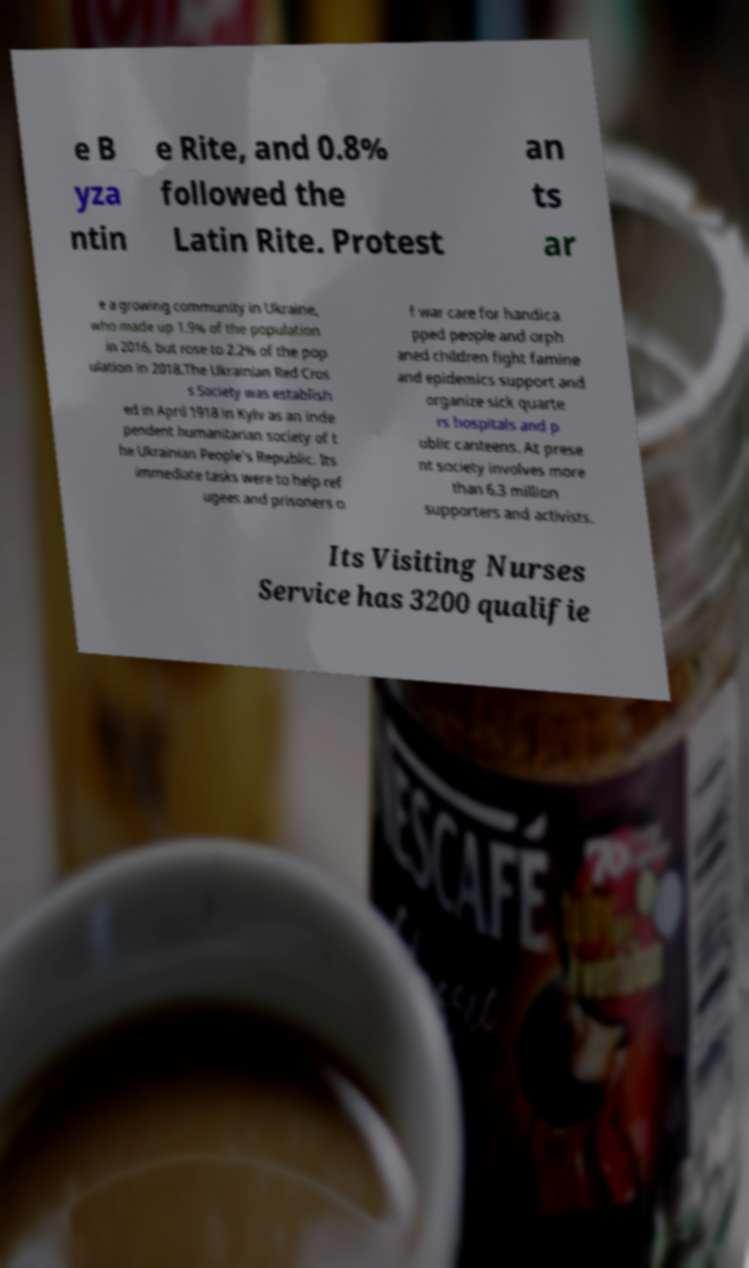Please identify and transcribe the text found in this image. e B yza ntin e Rite, and 0.8% followed the Latin Rite. Protest an ts ar e a growing community in Ukraine, who made up 1.9% of the population in 2016, but rose to 2.2% of the pop ulation in 2018.The Ukrainian Red Cros s Society was establish ed in April 1918 in Kyiv as an inde pendent humanitarian society of t he Ukrainian People's Republic. Its immediate tasks were to help ref ugees and prisoners o f war care for handica pped people and orph aned children fight famine and epidemics support and organize sick quarte rs hospitals and p ublic canteens. At prese nt society involves more than 6.3 million supporters and activists. Its Visiting Nurses Service has 3200 qualifie 